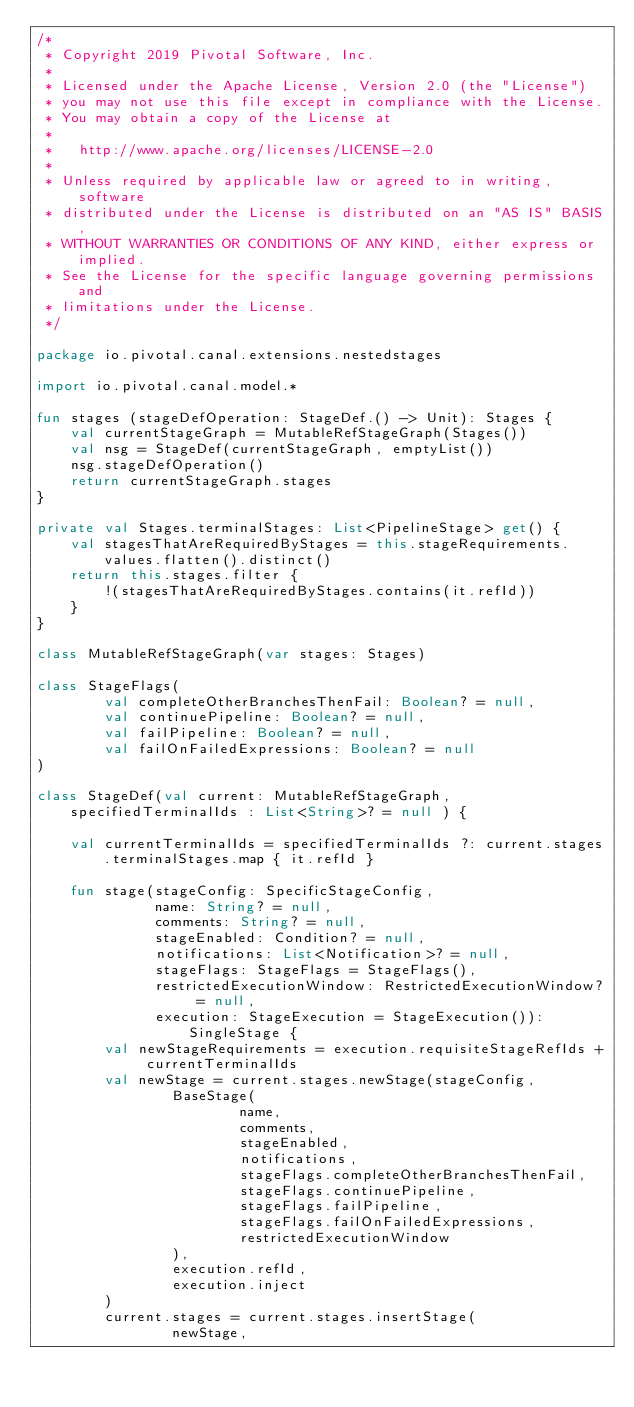<code> <loc_0><loc_0><loc_500><loc_500><_Kotlin_>/*
 * Copyright 2019 Pivotal Software, Inc.
 *
 * Licensed under the Apache License, Version 2.0 (the "License")
 * you may not use this file except in compliance with the License.
 * You may obtain a copy of the License at
 *
 *   http://www.apache.org/licenses/LICENSE-2.0
 *
 * Unless required by applicable law or agreed to in writing, software
 * distributed under the License is distributed on an "AS IS" BASIS,
 * WITHOUT WARRANTIES OR CONDITIONS OF ANY KIND, either express or implied.
 * See the License for the specific language governing permissions and
 * limitations under the License.
 */

package io.pivotal.canal.extensions.nestedstages

import io.pivotal.canal.model.*

fun stages (stageDefOperation: StageDef.() -> Unit): Stages {
    val currentStageGraph = MutableRefStageGraph(Stages())
    val nsg = StageDef(currentStageGraph, emptyList())
    nsg.stageDefOperation()
    return currentStageGraph.stages
}

private val Stages.terminalStages: List<PipelineStage> get() {
    val stagesThatAreRequiredByStages = this.stageRequirements.values.flatten().distinct()
    return this.stages.filter {
        !(stagesThatAreRequiredByStages.contains(it.refId))
    }
}

class MutableRefStageGraph(var stages: Stages)

class StageFlags(
        val completeOtherBranchesThenFail: Boolean? = null,
        val continuePipeline: Boolean? = null,
        val failPipeline: Boolean? = null,
        val failOnFailedExpressions: Boolean? = null
)

class StageDef(val current: MutableRefStageGraph, specifiedTerminalIds : List<String>? = null ) {

    val currentTerminalIds = specifiedTerminalIds ?: current.stages.terminalStages.map { it.refId }

    fun stage(stageConfig: SpecificStageConfig,
              name: String? = null,
              comments: String? = null,
              stageEnabled: Condition? = null,
              notifications: List<Notification>? = null,
              stageFlags: StageFlags = StageFlags(),
              restrictedExecutionWindow: RestrictedExecutionWindow? = null,
              execution: StageExecution = StageExecution()): SingleStage {
        val newStageRequirements = execution.requisiteStageRefIds + currentTerminalIds
        val newStage = current.stages.newStage(stageConfig,
                BaseStage(
                        name,
                        comments,
                        stageEnabled,
                        notifications,
                        stageFlags.completeOtherBranchesThenFail,
                        stageFlags.continuePipeline,
                        stageFlags.failPipeline,
                        stageFlags.failOnFailedExpressions,
                        restrictedExecutionWindow
                ),
                execution.refId,
                execution.inject
        )
        current.stages = current.stages.insertStage(
                newStage,</code> 